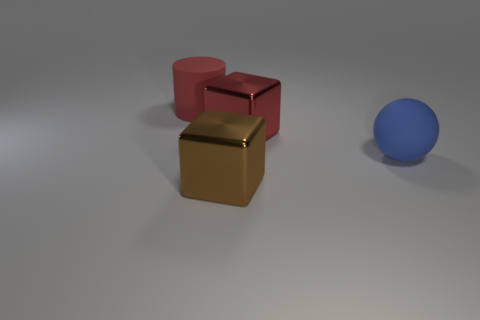What number of other cylinders have the same size as the rubber cylinder?
Provide a succinct answer. 0. What material is the object that is the same color as the matte cylinder?
Ensure brevity in your answer.  Metal. Is the shape of the object that is in front of the blue matte thing the same as  the red matte object?
Your response must be concise. No. Are there fewer big shiny objects that are on the right side of the brown block than purple objects?
Give a very brief answer. No. Is there another large rubber sphere of the same color as the big rubber ball?
Ensure brevity in your answer.  No. Is the shape of the red shiny object the same as the red thing to the left of the large brown block?
Your answer should be compact. No. Are there any small red spheres that have the same material as the big red cylinder?
Ensure brevity in your answer.  No. Are there any big matte balls to the left of the thing behind the big red thing that is on the right side of the brown metallic block?
Your answer should be compact. No. What number of other objects are there of the same shape as the big blue thing?
Provide a short and direct response. 0. The big rubber thing that is to the right of the big red thing that is to the left of the big shiny object in front of the big blue sphere is what color?
Offer a very short reply. Blue. 